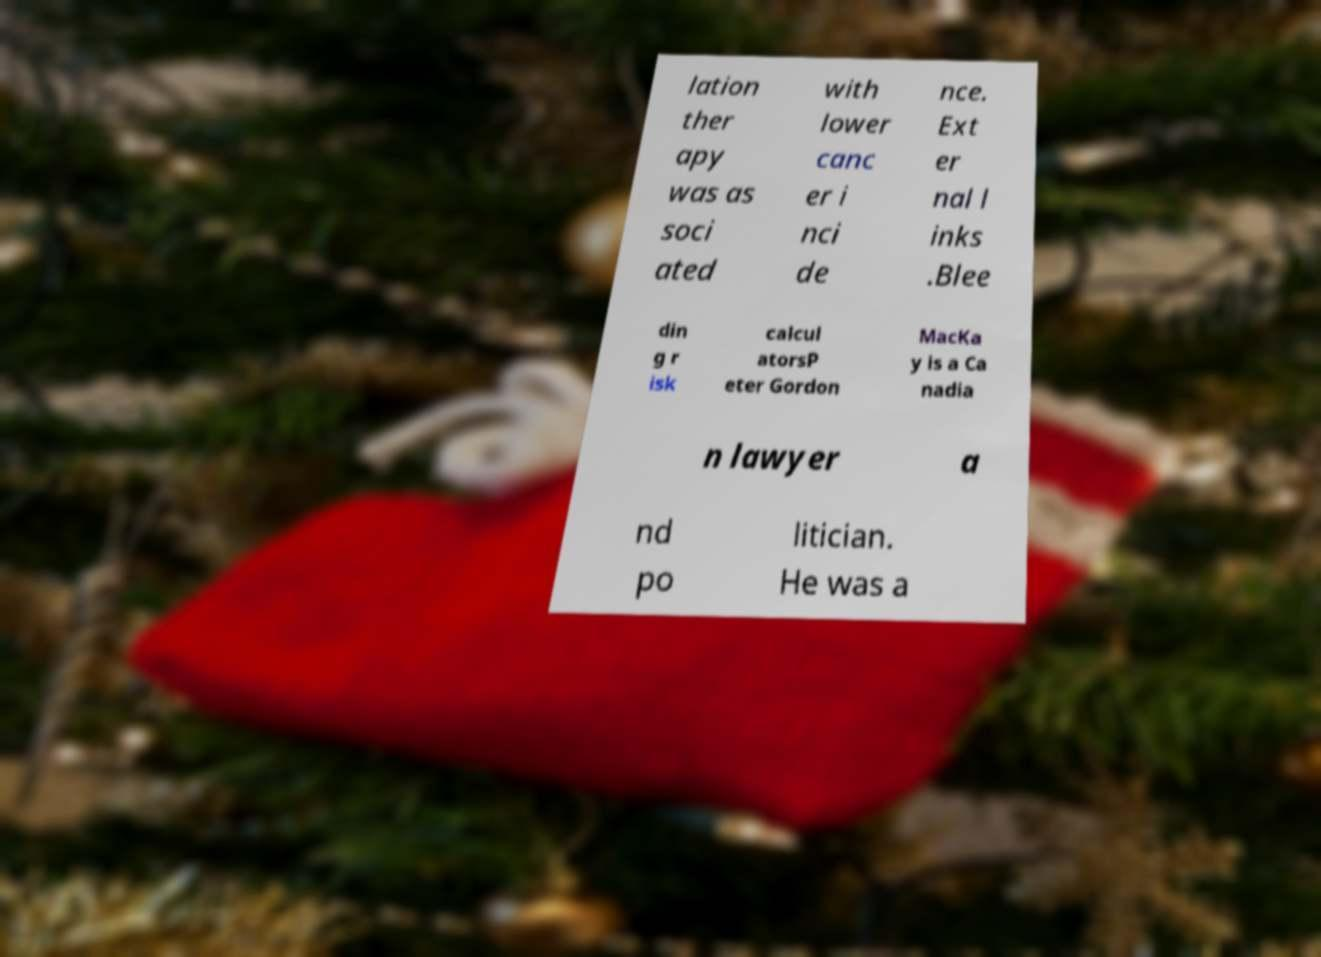I need the written content from this picture converted into text. Can you do that? lation ther apy was as soci ated with lower canc er i nci de nce. Ext er nal l inks .Blee din g r isk calcul atorsP eter Gordon MacKa y is a Ca nadia n lawyer a nd po litician. He was a 